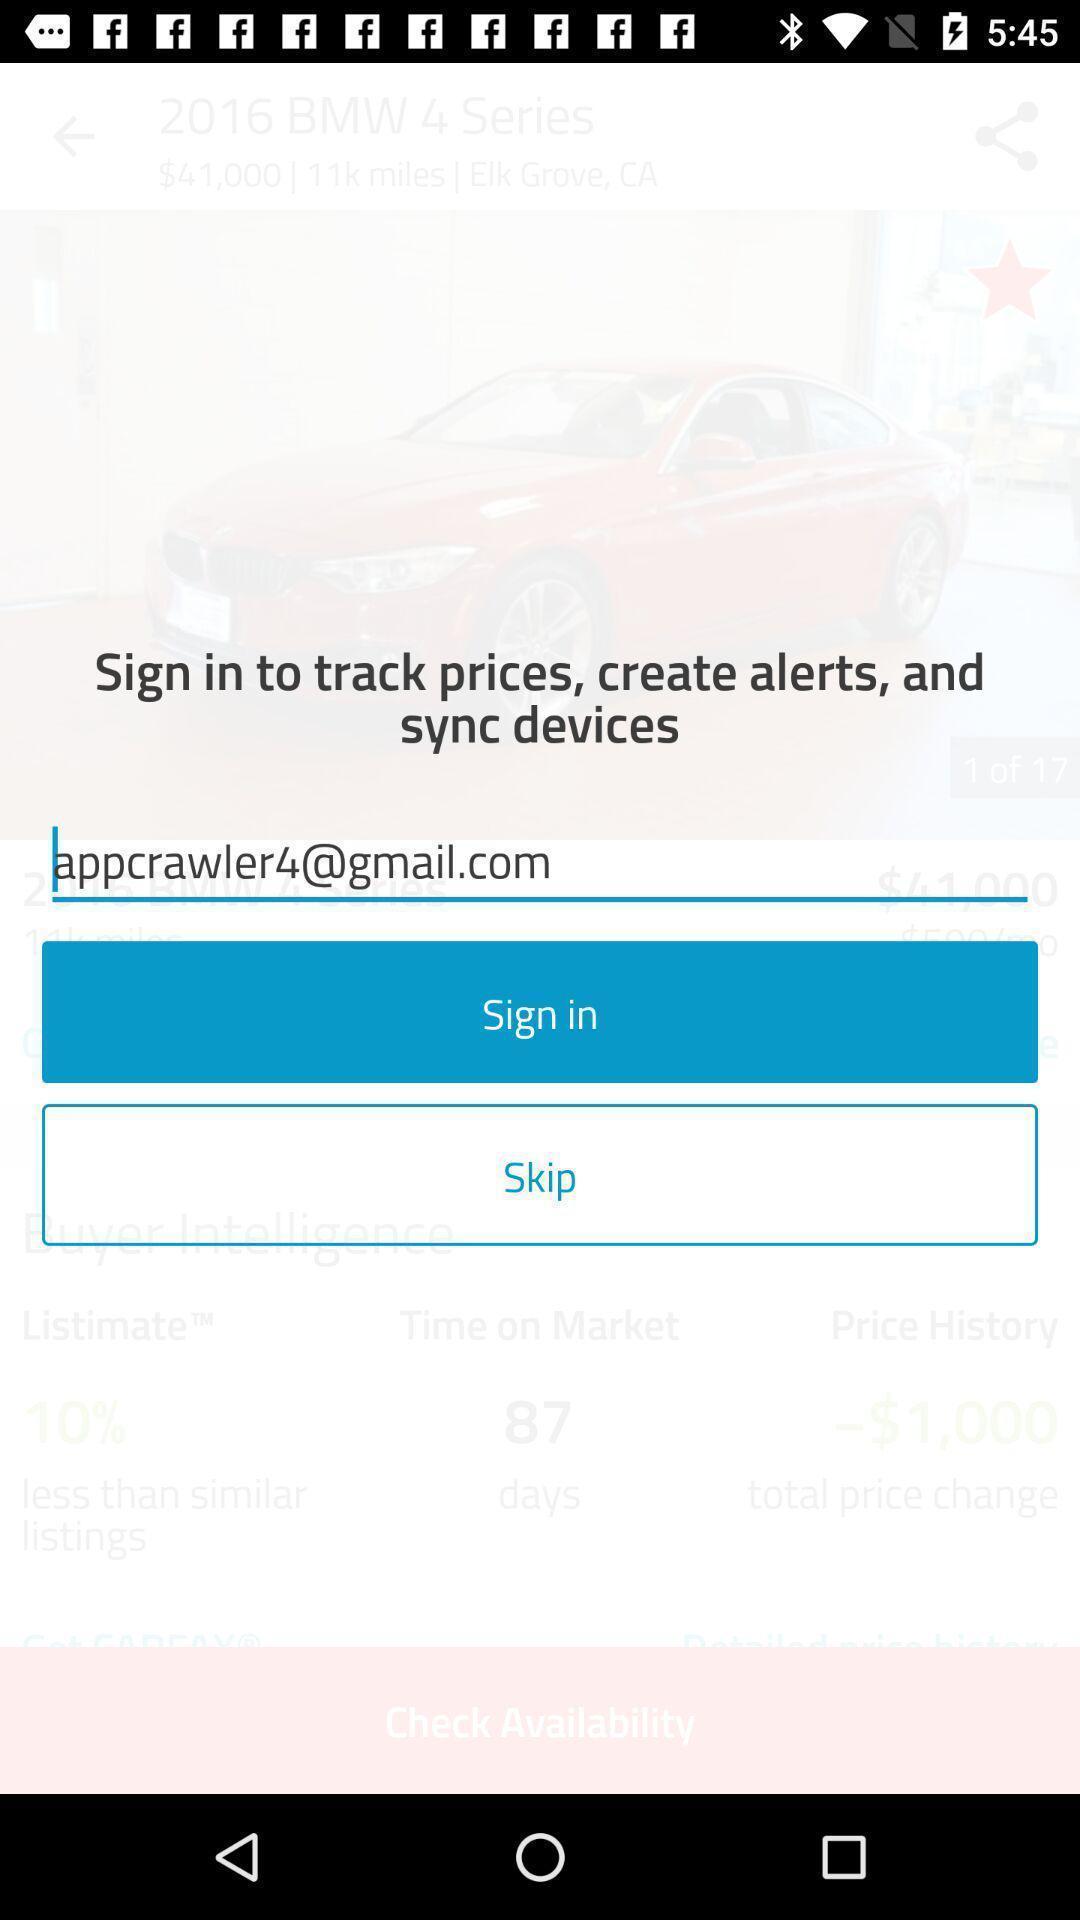Provide a detailed account of this screenshot. Sign in page of a social app. 